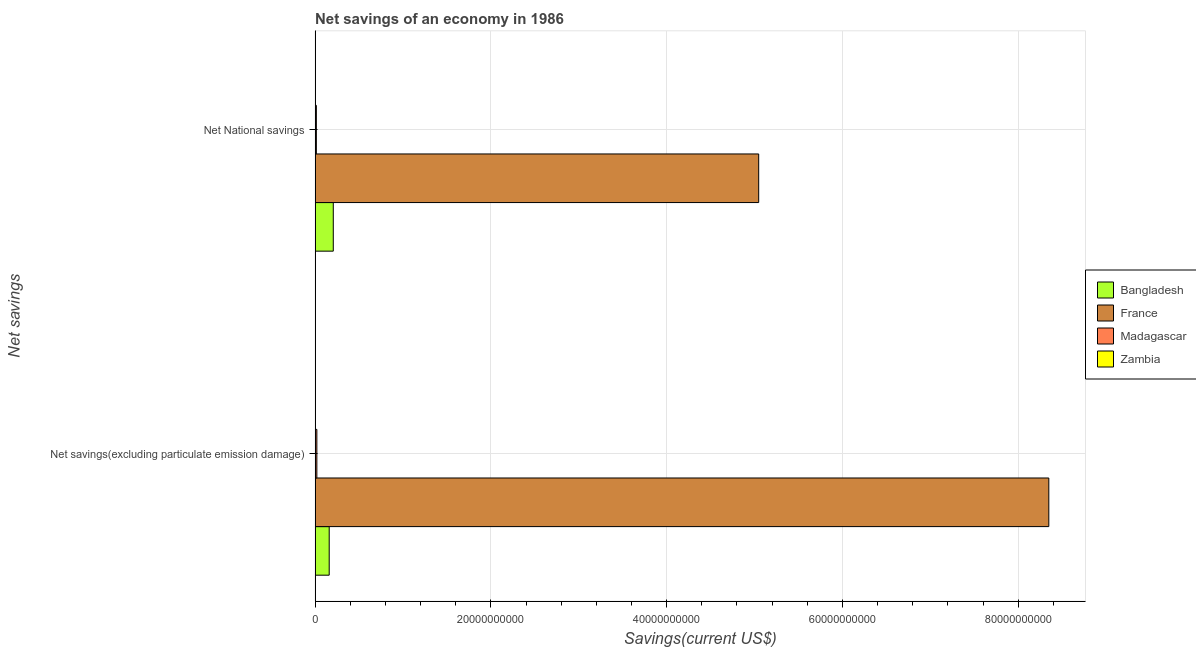Are the number of bars on each tick of the Y-axis equal?
Provide a short and direct response. Yes. How many bars are there on the 1st tick from the top?
Offer a very short reply. 3. How many bars are there on the 2nd tick from the bottom?
Your response must be concise. 3. What is the label of the 1st group of bars from the top?
Offer a very short reply. Net National savings. What is the net national savings in France?
Ensure brevity in your answer.  5.05e+1. Across all countries, what is the maximum net savings(excluding particulate emission damage)?
Give a very brief answer. 8.35e+1. Across all countries, what is the minimum net savings(excluding particulate emission damage)?
Give a very brief answer. 0. What is the total net savings(excluding particulate emission damage) in the graph?
Offer a very short reply. 8.53e+1. What is the difference between the net national savings in Bangladesh and that in Madagascar?
Keep it short and to the point. 1.93e+09. What is the difference between the net savings(excluding particulate emission damage) in France and the net national savings in Bangladesh?
Provide a short and direct response. 8.14e+1. What is the average net national savings per country?
Your response must be concise. 1.32e+1. What is the difference between the net national savings and net savings(excluding particulate emission damage) in Madagascar?
Your answer should be very brief. -5.75e+07. What is the ratio of the net national savings in Madagascar to that in France?
Your answer should be compact. 0. Is the net national savings in Madagascar less than that in Bangladesh?
Provide a short and direct response. Yes. How many bars are there?
Ensure brevity in your answer.  6. What is the title of the graph?
Provide a short and direct response. Net savings of an economy in 1986. What is the label or title of the X-axis?
Provide a succinct answer. Savings(current US$). What is the label or title of the Y-axis?
Ensure brevity in your answer.  Net savings. What is the Savings(current US$) in Bangladesh in Net savings(excluding particulate emission damage)?
Your answer should be very brief. 1.60e+09. What is the Savings(current US$) of France in Net savings(excluding particulate emission damage)?
Ensure brevity in your answer.  8.35e+1. What is the Savings(current US$) of Madagascar in Net savings(excluding particulate emission damage)?
Your answer should be very brief. 2.00e+08. What is the Savings(current US$) of Zambia in Net savings(excluding particulate emission damage)?
Your answer should be very brief. 0. What is the Savings(current US$) in Bangladesh in Net National savings?
Offer a very short reply. 2.07e+09. What is the Savings(current US$) of France in Net National savings?
Your answer should be compact. 5.05e+1. What is the Savings(current US$) of Madagascar in Net National savings?
Offer a very short reply. 1.43e+08. Across all Net savings, what is the maximum Savings(current US$) of Bangladesh?
Make the answer very short. 2.07e+09. Across all Net savings, what is the maximum Savings(current US$) in France?
Provide a succinct answer. 8.35e+1. Across all Net savings, what is the maximum Savings(current US$) in Madagascar?
Offer a terse response. 2.00e+08. Across all Net savings, what is the minimum Savings(current US$) of Bangladesh?
Your response must be concise. 1.60e+09. Across all Net savings, what is the minimum Savings(current US$) of France?
Give a very brief answer. 5.05e+1. Across all Net savings, what is the minimum Savings(current US$) in Madagascar?
Make the answer very short. 1.43e+08. What is the total Savings(current US$) in Bangladesh in the graph?
Your answer should be very brief. 3.67e+09. What is the total Savings(current US$) of France in the graph?
Keep it short and to the point. 1.34e+11. What is the total Savings(current US$) of Madagascar in the graph?
Offer a terse response. 3.43e+08. What is the total Savings(current US$) in Zambia in the graph?
Offer a very short reply. 0. What is the difference between the Savings(current US$) in Bangladesh in Net savings(excluding particulate emission damage) and that in Net National savings?
Provide a succinct answer. -4.64e+08. What is the difference between the Savings(current US$) of France in Net savings(excluding particulate emission damage) and that in Net National savings?
Provide a short and direct response. 3.30e+1. What is the difference between the Savings(current US$) of Madagascar in Net savings(excluding particulate emission damage) and that in Net National savings?
Your response must be concise. 5.75e+07. What is the difference between the Savings(current US$) of Bangladesh in Net savings(excluding particulate emission damage) and the Savings(current US$) of France in Net National savings?
Provide a succinct answer. -4.89e+1. What is the difference between the Savings(current US$) in Bangladesh in Net savings(excluding particulate emission damage) and the Savings(current US$) in Madagascar in Net National savings?
Your answer should be very brief. 1.46e+09. What is the difference between the Savings(current US$) of France in Net savings(excluding particulate emission damage) and the Savings(current US$) of Madagascar in Net National savings?
Provide a succinct answer. 8.33e+1. What is the average Savings(current US$) in Bangladesh per Net savings?
Make the answer very short. 1.84e+09. What is the average Savings(current US$) of France per Net savings?
Offer a terse response. 6.70e+1. What is the average Savings(current US$) in Madagascar per Net savings?
Your response must be concise. 1.71e+08. What is the average Savings(current US$) of Zambia per Net savings?
Make the answer very short. 0. What is the difference between the Savings(current US$) in Bangladesh and Savings(current US$) in France in Net savings(excluding particulate emission damage)?
Keep it short and to the point. -8.19e+1. What is the difference between the Savings(current US$) in Bangladesh and Savings(current US$) in Madagascar in Net savings(excluding particulate emission damage)?
Your response must be concise. 1.40e+09. What is the difference between the Savings(current US$) in France and Savings(current US$) in Madagascar in Net savings(excluding particulate emission damage)?
Offer a very short reply. 8.33e+1. What is the difference between the Savings(current US$) of Bangladesh and Savings(current US$) of France in Net National savings?
Your answer should be very brief. -4.84e+1. What is the difference between the Savings(current US$) of Bangladesh and Savings(current US$) of Madagascar in Net National savings?
Your answer should be compact. 1.93e+09. What is the difference between the Savings(current US$) of France and Savings(current US$) of Madagascar in Net National savings?
Make the answer very short. 5.03e+1. What is the ratio of the Savings(current US$) in Bangladesh in Net savings(excluding particulate emission damage) to that in Net National savings?
Your answer should be compact. 0.78. What is the ratio of the Savings(current US$) in France in Net savings(excluding particulate emission damage) to that in Net National savings?
Your answer should be very brief. 1.65. What is the ratio of the Savings(current US$) of Madagascar in Net savings(excluding particulate emission damage) to that in Net National savings?
Ensure brevity in your answer.  1.4. What is the difference between the highest and the second highest Savings(current US$) in Bangladesh?
Your answer should be compact. 4.64e+08. What is the difference between the highest and the second highest Savings(current US$) of France?
Your answer should be compact. 3.30e+1. What is the difference between the highest and the second highest Savings(current US$) of Madagascar?
Provide a succinct answer. 5.75e+07. What is the difference between the highest and the lowest Savings(current US$) in Bangladesh?
Your answer should be compact. 4.64e+08. What is the difference between the highest and the lowest Savings(current US$) in France?
Your answer should be very brief. 3.30e+1. What is the difference between the highest and the lowest Savings(current US$) in Madagascar?
Keep it short and to the point. 5.75e+07. 